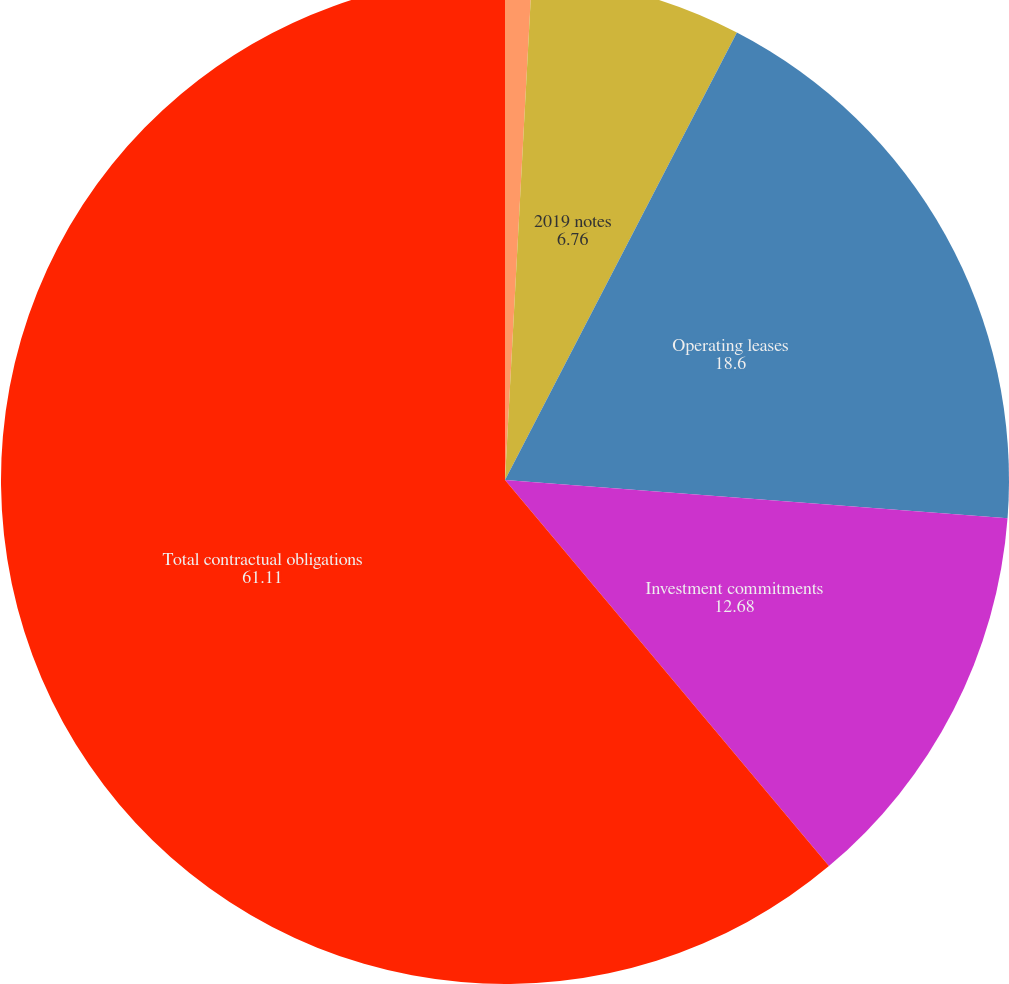<chart> <loc_0><loc_0><loc_500><loc_500><pie_chart><fcel>2017 notes<fcel>2019 notes<fcel>Operating leases<fcel>Investment commitments<fcel>Total contractual obligations<nl><fcel>0.85%<fcel>6.76%<fcel>18.6%<fcel>12.68%<fcel>61.11%<nl></chart> 